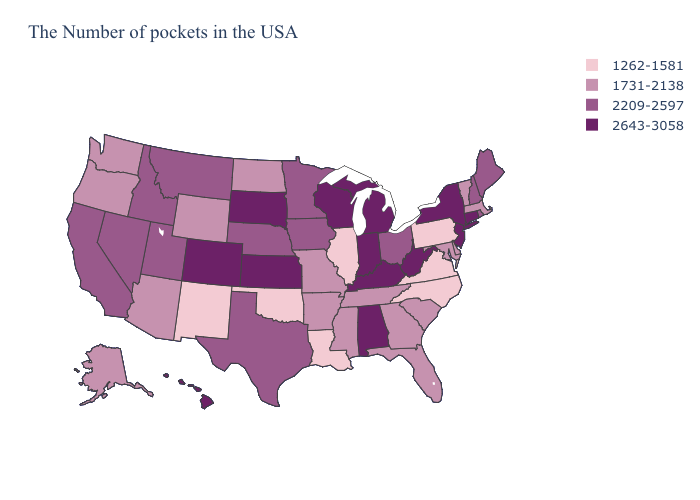Which states have the lowest value in the South?
Short answer required. Virginia, North Carolina, Louisiana, Oklahoma. Name the states that have a value in the range 1731-2138?
Give a very brief answer. Massachusetts, Vermont, Delaware, Maryland, South Carolina, Florida, Georgia, Tennessee, Mississippi, Missouri, Arkansas, North Dakota, Wyoming, Arizona, Washington, Oregon, Alaska. What is the lowest value in states that border Nebraska?
Answer briefly. 1731-2138. What is the value of Connecticut?
Short answer required. 2643-3058. Name the states that have a value in the range 2643-3058?
Concise answer only. Connecticut, New York, New Jersey, West Virginia, Michigan, Kentucky, Indiana, Alabama, Wisconsin, Kansas, South Dakota, Colorado, Hawaii. What is the value of Minnesota?
Give a very brief answer. 2209-2597. Which states hav the highest value in the Northeast?
Keep it brief. Connecticut, New York, New Jersey. Name the states that have a value in the range 2209-2597?
Keep it brief. Maine, Rhode Island, New Hampshire, Ohio, Minnesota, Iowa, Nebraska, Texas, Utah, Montana, Idaho, Nevada, California. Which states have the highest value in the USA?
Be succinct. Connecticut, New York, New Jersey, West Virginia, Michigan, Kentucky, Indiana, Alabama, Wisconsin, Kansas, South Dakota, Colorado, Hawaii. Does Texas have the same value as Maine?
Concise answer only. Yes. Name the states that have a value in the range 1731-2138?
Keep it brief. Massachusetts, Vermont, Delaware, Maryland, South Carolina, Florida, Georgia, Tennessee, Mississippi, Missouri, Arkansas, North Dakota, Wyoming, Arizona, Washington, Oregon, Alaska. Which states have the lowest value in the West?
Short answer required. New Mexico. Does Mississippi have the same value as Delaware?
Write a very short answer. Yes. What is the value of Pennsylvania?
Answer briefly. 1262-1581. What is the lowest value in the West?
Give a very brief answer. 1262-1581. 